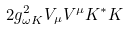Convert formula to latex. <formula><loc_0><loc_0><loc_500><loc_500>2 g _ { \omega K } ^ { 2 } V _ { \mu } V ^ { \mu } K ^ { * } K</formula> 